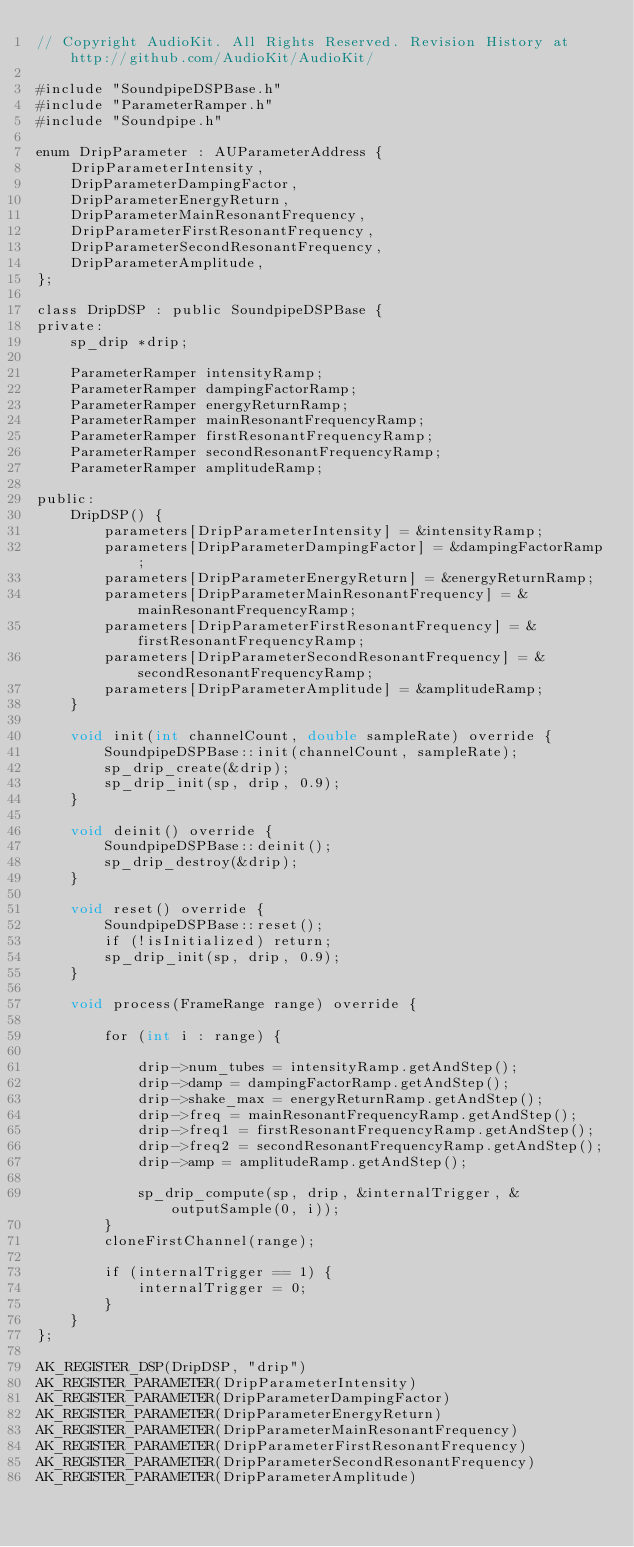Convert code to text. <code><loc_0><loc_0><loc_500><loc_500><_ObjectiveC_>// Copyright AudioKit. All Rights Reserved. Revision History at http://github.com/AudioKit/AudioKit/

#include "SoundpipeDSPBase.h"
#include "ParameterRamper.h"
#include "Soundpipe.h"

enum DripParameter : AUParameterAddress {
    DripParameterIntensity,
    DripParameterDampingFactor,
    DripParameterEnergyReturn,
    DripParameterMainResonantFrequency,
    DripParameterFirstResonantFrequency,
    DripParameterSecondResonantFrequency,
    DripParameterAmplitude,
};

class DripDSP : public SoundpipeDSPBase {
private:
    sp_drip *drip;

    ParameterRamper intensityRamp;
    ParameterRamper dampingFactorRamp;
    ParameterRamper energyReturnRamp;
    ParameterRamper mainResonantFrequencyRamp;
    ParameterRamper firstResonantFrequencyRamp;
    ParameterRamper secondResonantFrequencyRamp;
    ParameterRamper amplitudeRamp;

public:
    DripDSP() {
        parameters[DripParameterIntensity] = &intensityRamp;
        parameters[DripParameterDampingFactor] = &dampingFactorRamp;
        parameters[DripParameterEnergyReturn] = &energyReturnRamp;
        parameters[DripParameterMainResonantFrequency] = &mainResonantFrequencyRamp;
        parameters[DripParameterFirstResonantFrequency] = &firstResonantFrequencyRamp;
        parameters[DripParameterSecondResonantFrequency] = &secondResonantFrequencyRamp;
        parameters[DripParameterAmplitude] = &amplitudeRamp;
    }

    void init(int channelCount, double sampleRate) override {
        SoundpipeDSPBase::init(channelCount, sampleRate);
        sp_drip_create(&drip);
        sp_drip_init(sp, drip, 0.9);
    }

    void deinit() override {
        SoundpipeDSPBase::deinit();
        sp_drip_destroy(&drip);
    }

    void reset() override {
        SoundpipeDSPBase::reset();
        if (!isInitialized) return;
        sp_drip_init(sp, drip, 0.9);
    }

    void process(FrameRange range) override {

        for (int i : range) {

            drip->num_tubes = intensityRamp.getAndStep();
            drip->damp = dampingFactorRamp.getAndStep();
            drip->shake_max = energyReturnRamp.getAndStep();
            drip->freq = mainResonantFrequencyRamp.getAndStep();
            drip->freq1 = firstResonantFrequencyRamp.getAndStep();
            drip->freq2 = secondResonantFrequencyRamp.getAndStep();
            drip->amp = amplitudeRamp.getAndStep();

            sp_drip_compute(sp, drip, &internalTrigger, &outputSample(0, i));
        }
        cloneFirstChannel(range);

        if (internalTrigger == 1) {
            internalTrigger = 0;
        }
    }
};

AK_REGISTER_DSP(DripDSP, "drip")
AK_REGISTER_PARAMETER(DripParameterIntensity)
AK_REGISTER_PARAMETER(DripParameterDampingFactor)
AK_REGISTER_PARAMETER(DripParameterEnergyReturn)
AK_REGISTER_PARAMETER(DripParameterMainResonantFrequency)
AK_REGISTER_PARAMETER(DripParameterFirstResonantFrequency)
AK_REGISTER_PARAMETER(DripParameterSecondResonantFrequency)
AK_REGISTER_PARAMETER(DripParameterAmplitude)
</code> 